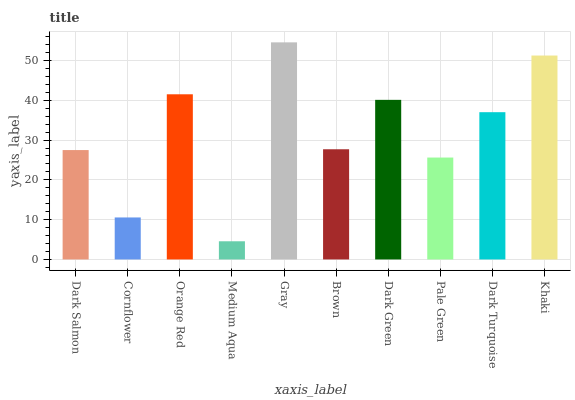Is Medium Aqua the minimum?
Answer yes or no. Yes. Is Gray the maximum?
Answer yes or no. Yes. Is Cornflower the minimum?
Answer yes or no. No. Is Cornflower the maximum?
Answer yes or no. No. Is Dark Salmon greater than Cornflower?
Answer yes or no. Yes. Is Cornflower less than Dark Salmon?
Answer yes or no. Yes. Is Cornflower greater than Dark Salmon?
Answer yes or no. No. Is Dark Salmon less than Cornflower?
Answer yes or no. No. Is Dark Turquoise the high median?
Answer yes or no. Yes. Is Brown the low median?
Answer yes or no. Yes. Is Khaki the high median?
Answer yes or no. No. Is Gray the low median?
Answer yes or no. No. 